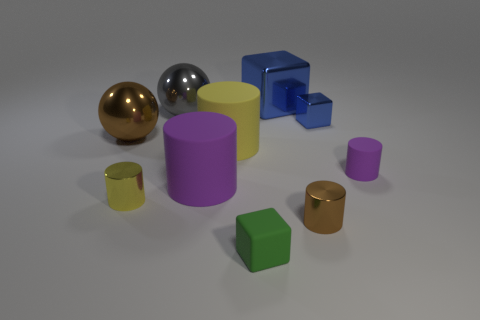Subtract all brown cubes. How many yellow cylinders are left? 2 Subtract all metallic cubes. How many cubes are left? 1 Subtract all brown cylinders. How many cylinders are left? 4 Subtract all brown cylinders. Subtract all green cubes. How many cylinders are left? 4 Add 9 big gray balls. How many big gray balls exist? 10 Subtract 0 cyan blocks. How many objects are left? 10 Subtract all blocks. How many objects are left? 7 Subtract all red rubber blocks. Subtract all matte cylinders. How many objects are left? 7 Add 7 brown objects. How many brown objects are left? 9 